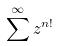<formula> <loc_0><loc_0><loc_500><loc_500>\sum ^ { \infty } z ^ { n ! }</formula> 